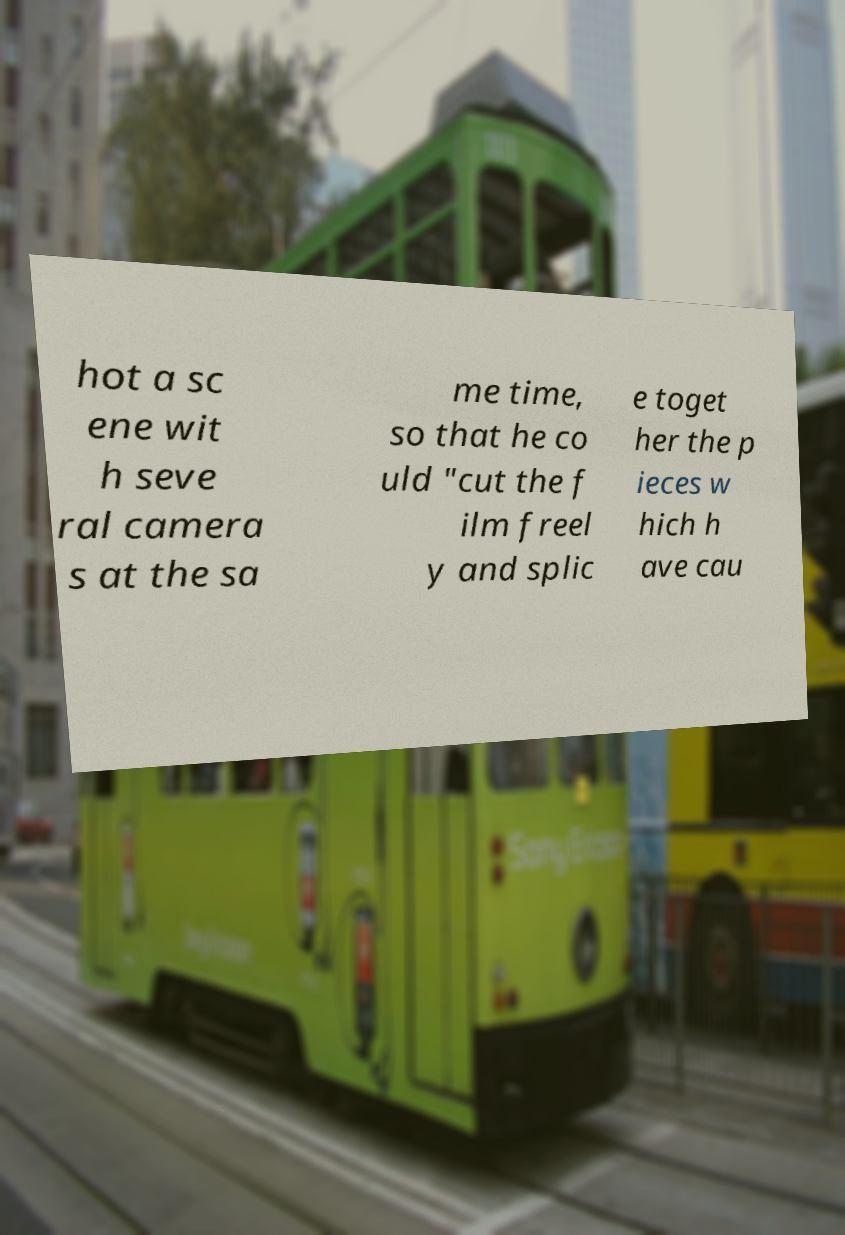Can you accurately transcribe the text from the provided image for me? hot a sc ene wit h seve ral camera s at the sa me time, so that he co uld "cut the f ilm freel y and splic e toget her the p ieces w hich h ave cau 